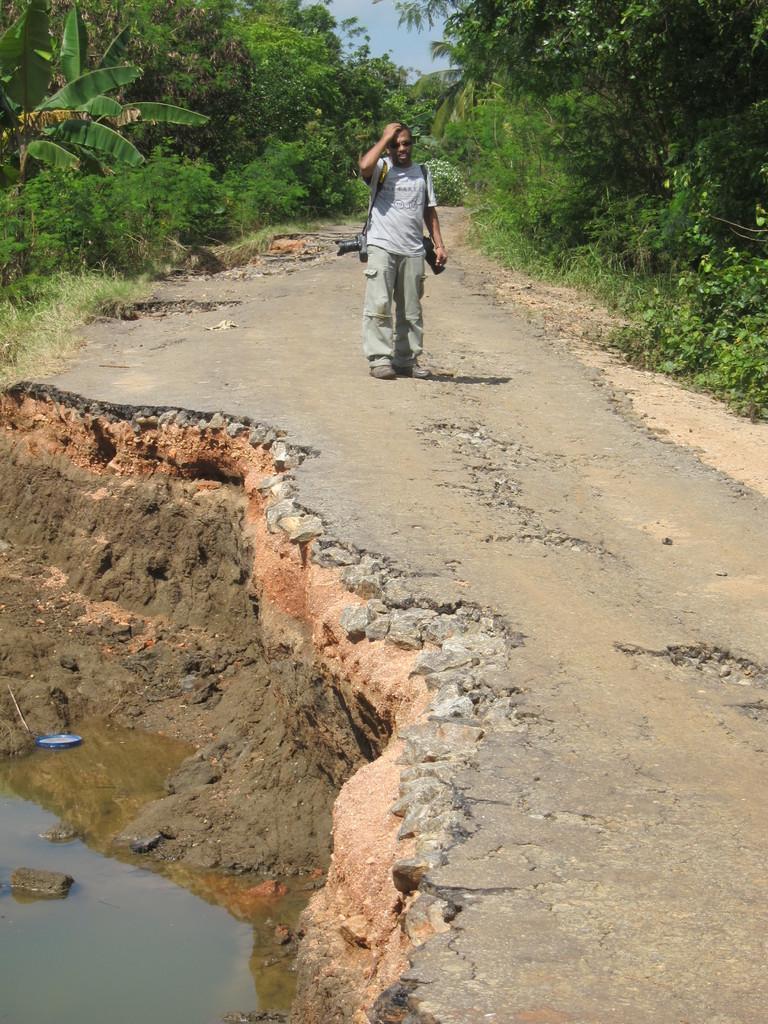Can you describe this image briefly? In the image we can see a person standing, wearing clothes, shoes, goggles and the person is carrying cameras. Here we can see the road, water and grass. We can even see trees, plants and the sky. 